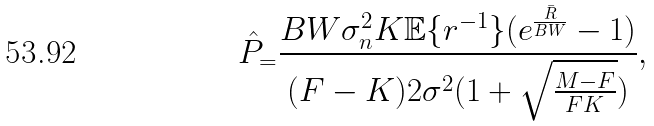Convert formula to latex. <formula><loc_0><loc_0><loc_500><loc_500>\hat { P } _ { = } \frac { B W \sigma _ { n } ^ { 2 } K \mathbb { E } \{ r ^ { - 1 } \} ( e ^ { \frac { \bar { R } } { B W } } - 1 ) } { ( F - K ) 2 \sigma ^ { 2 } ( 1 + \sqrt { \frac { M - F } { F K } } ) } ,</formula> 